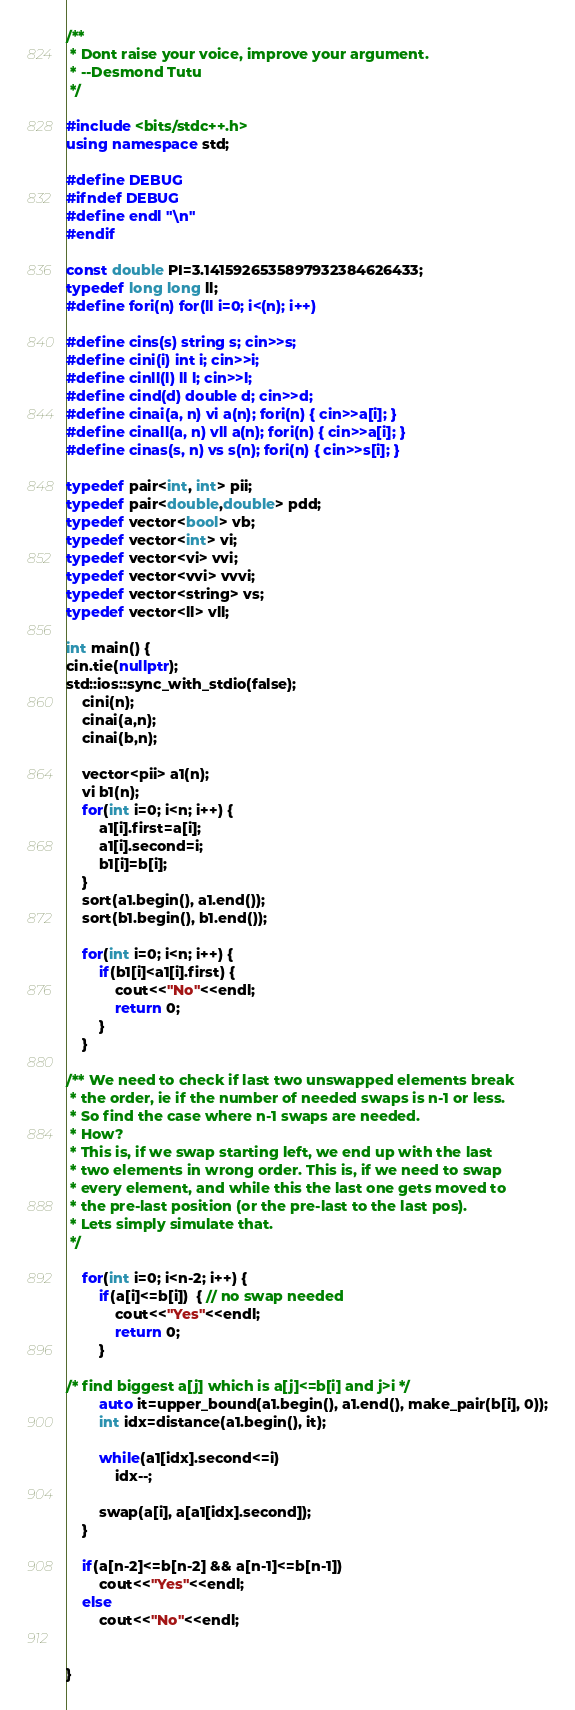Convert code to text. <code><loc_0><loc_0><loc_500><loc_500><_C++_>/** 
 * Dont raise your voice, improve your argument.
 * --Desmond Tutu
 */

#include <bits/stdc++.h>
using namespace std;

#define DEBUG
#ifndef DEBUG
#define endl "\n"
#endif

const double PI=3.1415926535897932384626433;
typedef long long ll;
#define fori(n) for(ll i=0; i<(n); i++)

#define cins(s) string s; cin>>s;
#define cini(i) int i; cin>>i;
#define cinll(l) ll l; cin>>l;
#define cind(d) double d; cin>>d;
#define cinai(a, n) vi a(n); fori(n) { cin>>a[i]; }
#define cinall(a, n) vll a(n); fori(n) { cin>>a[i]; }
#define cinas(s, n) vs s(n); fori(n) { cin>>s[i]; }

typedef pair<int, int> pii;
typedef pair<double,double> pdd;
typedef vector<bool> vb;
typedef vector<int> vi;
typedef vector<vi> vvi;
typedef vector<vvi> vvvi;
typedef vector<string> vs;
typedef vector<ll> vll;

int main() {
cin.tie(nullptr);
std::ios::sync_with_stdio(false);
    cini(n);
    cinai(a,n);
    cinai(b,n);

    vector<pii> a1(n);
    vi b1(n);
    for(int i=0; i<n; i++) {
        a1[i].first=a[i];
        a1[i].second=i;
        b1[i]=b[i];
    }
    sort(a1.begin(), a1.end());
    sort(b1.begin(), b1.end());

    for(int i=0; i<n; i++) {
        if(b1[i]<a1[i].first) {
            cout<<"No"<<endl;
            return 0;
        }
    }

/** We need to check if last two unswapped elements break
 * the order, ie if the number of needed swaps is n-1 or less.
 * So find the case where n-1 swaps are needed.
 * How?
 * This is, if we swap starting left, we end up with the last
 * two elements in wrong order. This is, if we need to swap 
 * every element, and while this the last one gets moved to 
 * the pre-last position (or the pre-last to the last pos).
 * Lets simply simulate that.
 */

    for(int i=0; i<n-2; i++) {
        if(a[i]<=b[i])  { // no swap needed
            cout<<"Yes"<<endl;
            return 0;
        }

/* find biggest a[j] which is a[j]<=b[i] and j>i */
        auto it=upper_bound(a1.begin(), a1.end(), make_pair(b[i], 0));
        int idx=distance(a1.begin(), it);

        while(a1[idx].second<=i)
            idx--;

        swap(a[i], a[a1[idx].second]);
    }

    if(a[n-2]<=b[n-2] && a[n-1]<=b[n-1])
        cout<<"Yes"<<endl;
    else
        cout<<"No"<<endl;
    

}

</code> 